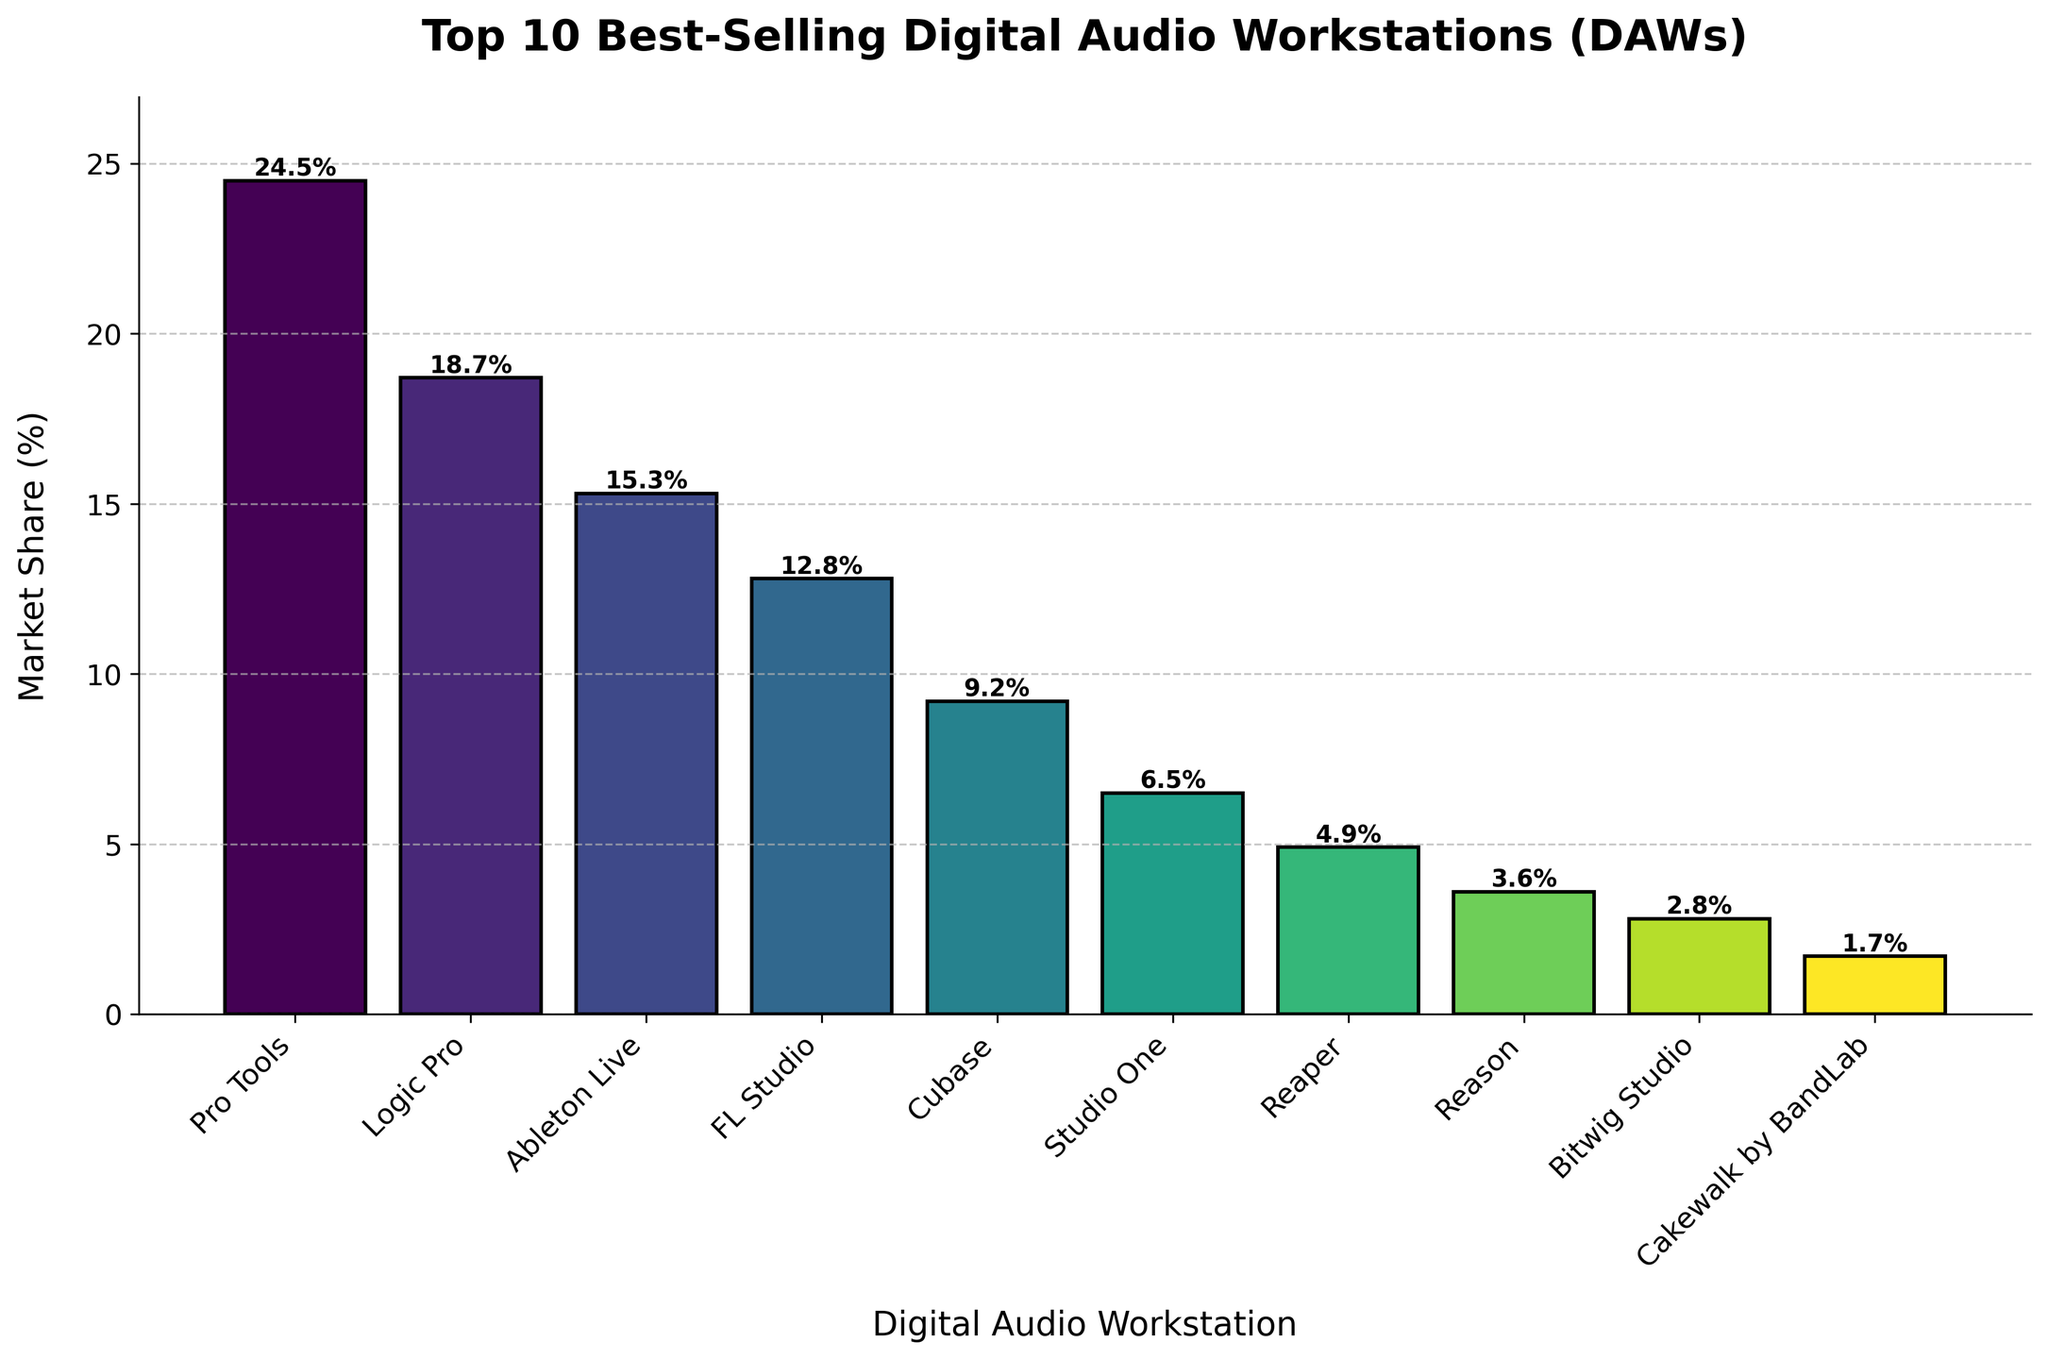What is the market share of Pro Tools? Identify the bar labeled "Pro Tools" and read the market share value. Pro Tools has a market share of 24.5%.
Answer: 24.5% Which DAW has the lowest market share? Find the shortest bar in the chart. The shortest bar represents "Cakewalk by BandLab" with a market share of 1.7%.
Answer: Cakewalk by BandLab What is the difference in market share between Logic Pro and Ableton Live? Identify the bars labeled "Logic Pro" and "Ableton Live" and note their market shares. Calculate the difference: 18.7% - 15.3% = 3.4%.
Answer: 3.4% What is the combined market share of FL Studio and Cubase? Identify the bars labeled "FL Studio" and "Cubase," then sum their market shares: 12.8% + 9.2% = 22%.
Answer: 22% Which DAWs have a market share greater than 10%? Identify the bars with heights above 10%. These bars represent "Pro Tools," "Logic Pro," "Ableton Live," and "FL Studio."
Answer: Pro Tools, Logic Pro, Ableton Live, FL Studio How many DAWs have a market share less than 5%? Count the bars with heights below 5%. These bars are "Reaper," "Reason," "Bitwig Studio," and "Cakewalk by BandLab," totaling 4 DAWs.
Answer: 4 Between Studio One and Reaper, which has a higher market share and by how much? Compare the heights of the bars labeled "Studio One" and "Reaper." Studio One has a market share of 6.5%, while Reaper has 4.9%. The difference is 6.5% - 4.9% = 1.6%.
Answer: Studio One, 1.6% What is the average market share of the top 3 best-selling DAWs? Identify the top 3 DAWs: "Pro Tools" (24.5%), "Logic Pro" (18.7%), and "Ableton Live" (15.3%). Calculate the average: (24.5% + 18.7% + 15.3%) / 3 = 19.5%.
Answer: 19.5% What is the market share range of the DAWs presented? Identify the highest and lowest market shares: "Pro Tools" at 24.5% and "Cakewalk by BandLab" at 1.7%. Calculate the range: 24.5% - 1.7% = 22.8%
Answer: 22.8% Are there any DAWs with precisely the same market share? Visually inspect the heights of the bars to see if any are identical. There are no DAWs with exactly identical market shares.
Answer: No 